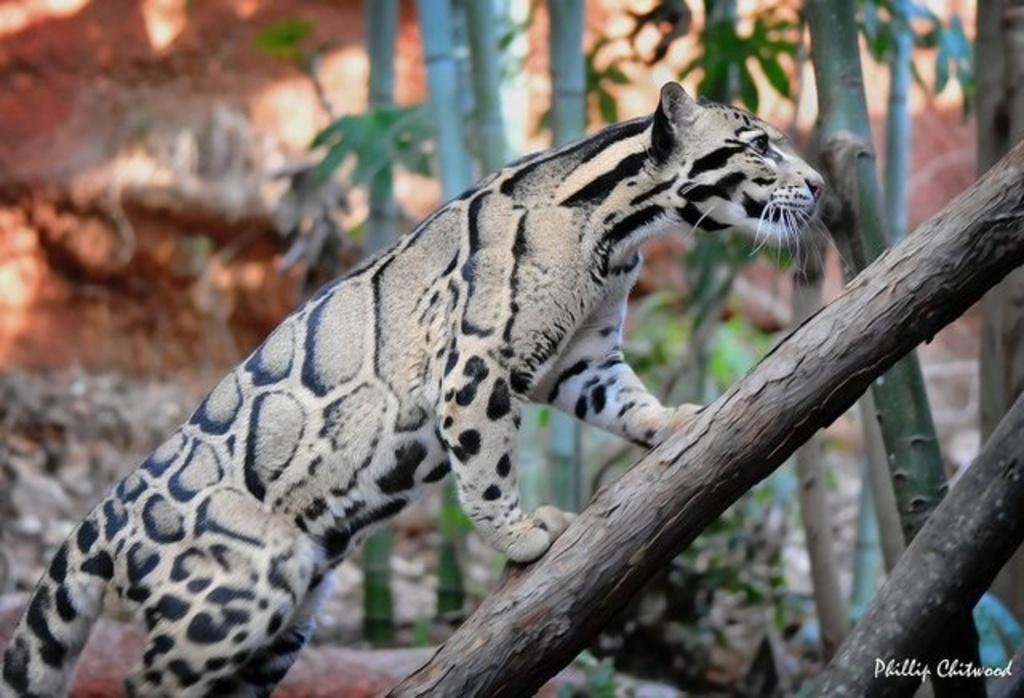What is on the tree branch in the image? There is an animal on a tree branch in the image. What can be seen in the background of the image? There are trees and stones in the background of the image. What type of shade does the grandfather provide for the animal in the image? There is no grandfather or shade present in the image; it only features an animal on a tree branch and trees and stones in the background. 